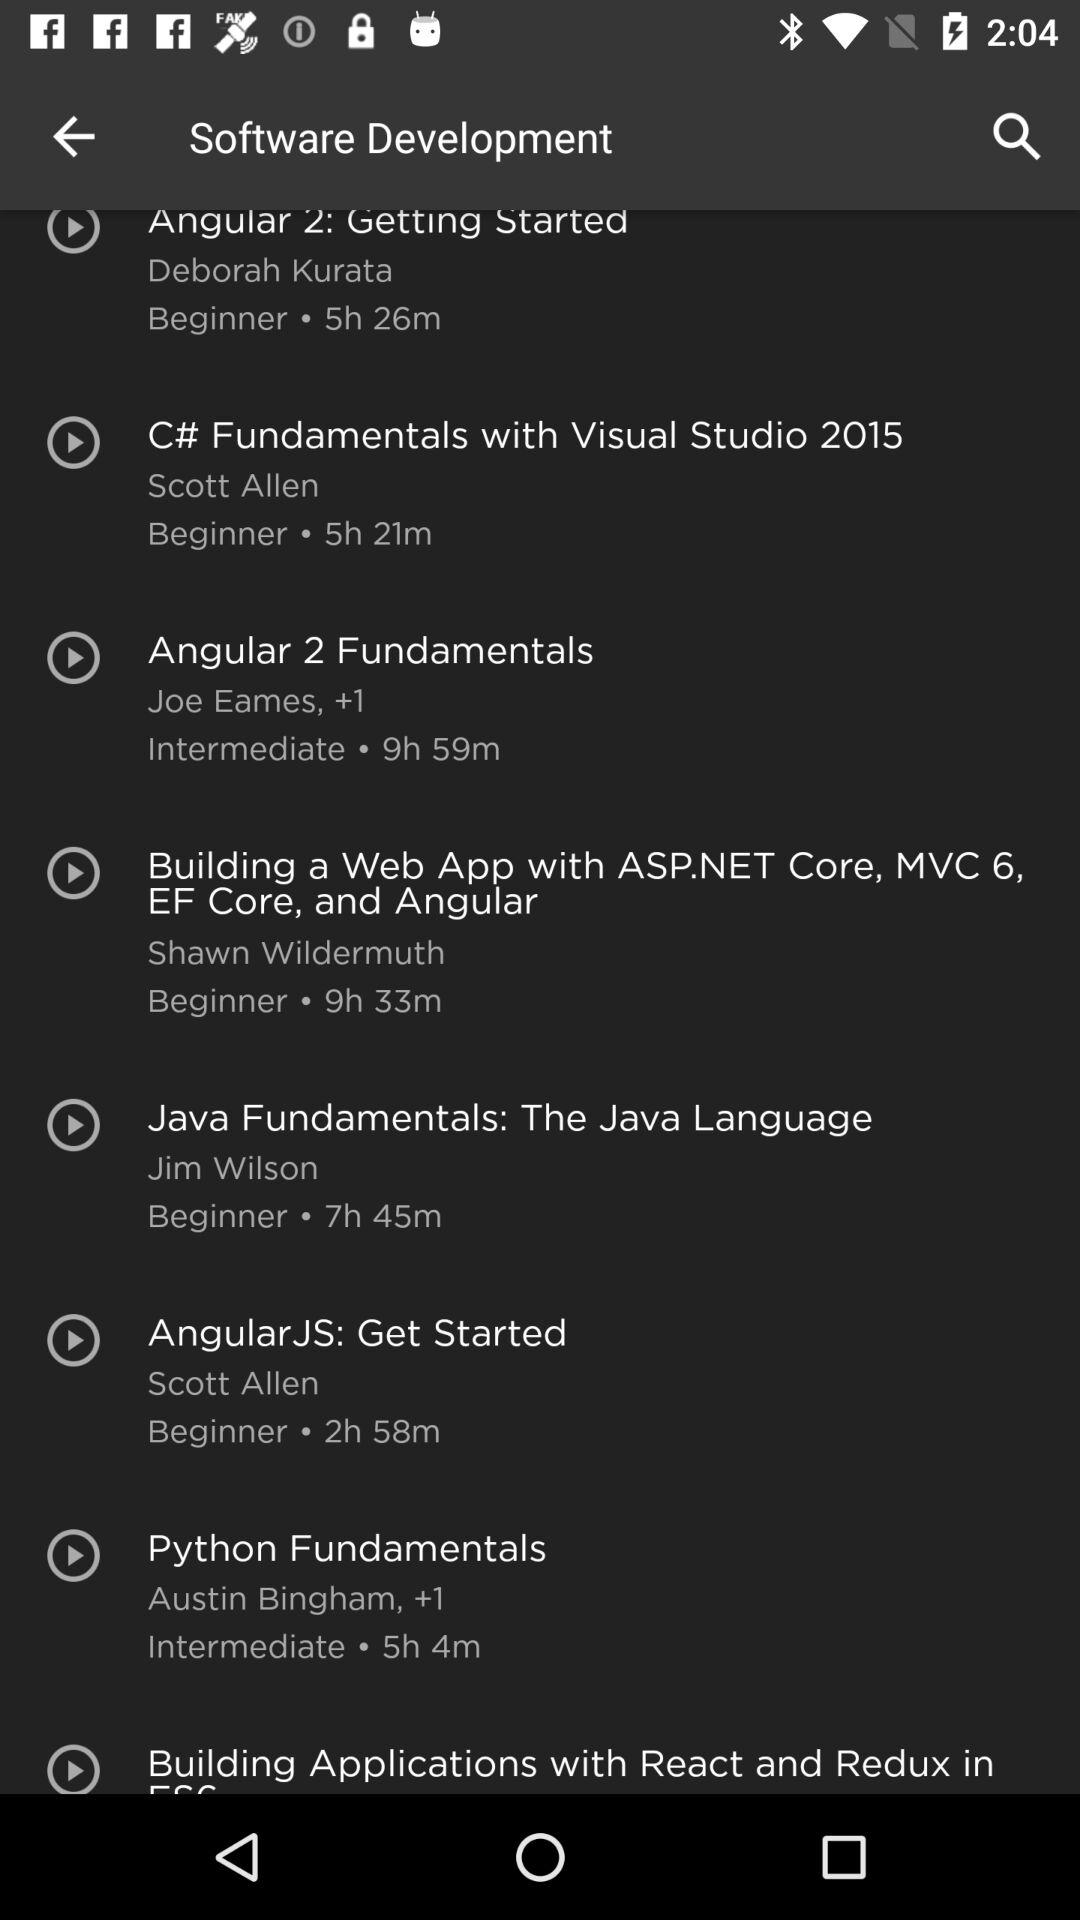Is there a course on this platform that deals with both Python and web development? Yes, the 'Building Applications with React and Redux in ES6' by Cory House could be an excellent choice. Though it focuses on React and Redux, these are often used in conjunction with Python in web development. This intermediate-level course is 6 hours and 13 minutes long. 